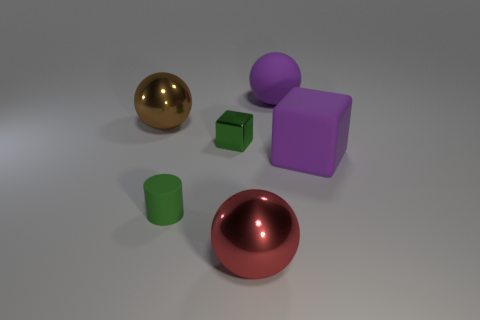What number of other objects are there of the same shape as the red thing?
Provide a succinct answer. 2. Do the big metallic object that is left of the matte cylinder and the big rubber cube have the same color?
Keep it short and to the point. No. Is there a tiny object that has the same color as the big rubber sphere?
Your answer should be compact. No. There is a green shiny thing; what number of green metal cubes are right of it?
Offer a very short reply. 0. How many other objects are the same size as the red metal object?
Your answer should be compact. 3. Are the block that is behind the purple block and the large sphere in front of the tiny green metal object made of the same material?
Provide a succinct answer. Yes. What is the color of the metal object that is the same size as the green matte cylinder?
Offer a terse response. Green. Is there any other thing of the same color as the cylinder?
Your answer should be very brief. Yes. There is a sphere in front of the matte cylinder on the left side of the big rubber thing left of the purple block; what size is it?
Offer a terse response. Large. There is a metal thing that is both behind the big cube and in front of the brown object; what is its color?
Your answer should be compact. Green. 